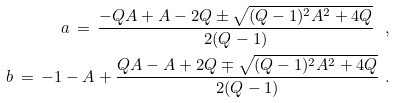<formula> <loc_0><loc_0><loc_500><loc_500>a \, = \, \frac { - Q A + A - 2 Q \pm \sqrt { ( Q - 1 ) ^ { 2 } A ^ { 2 } + 4 Q } } { 2 ( Q - 1 ) } \ , \\ b \, = \, - 1 - A + \frac { Q A - A + 2 Q \mp \sqrt { ( Q - 1 ) ^ { 2 } A ^ { 2 } + 4 Q } } { 2 ( Q - 1 ) } \ .</formula> 